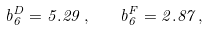Convert formula to latex. <formula><loc_0><loc_0><loc_500><loc_500>b _ { 6 } ^ { D } = 5 . 2 9 \, , \quad b _ { 6 } ^ { F } = 2 . 8 7 \, ,</formula> 